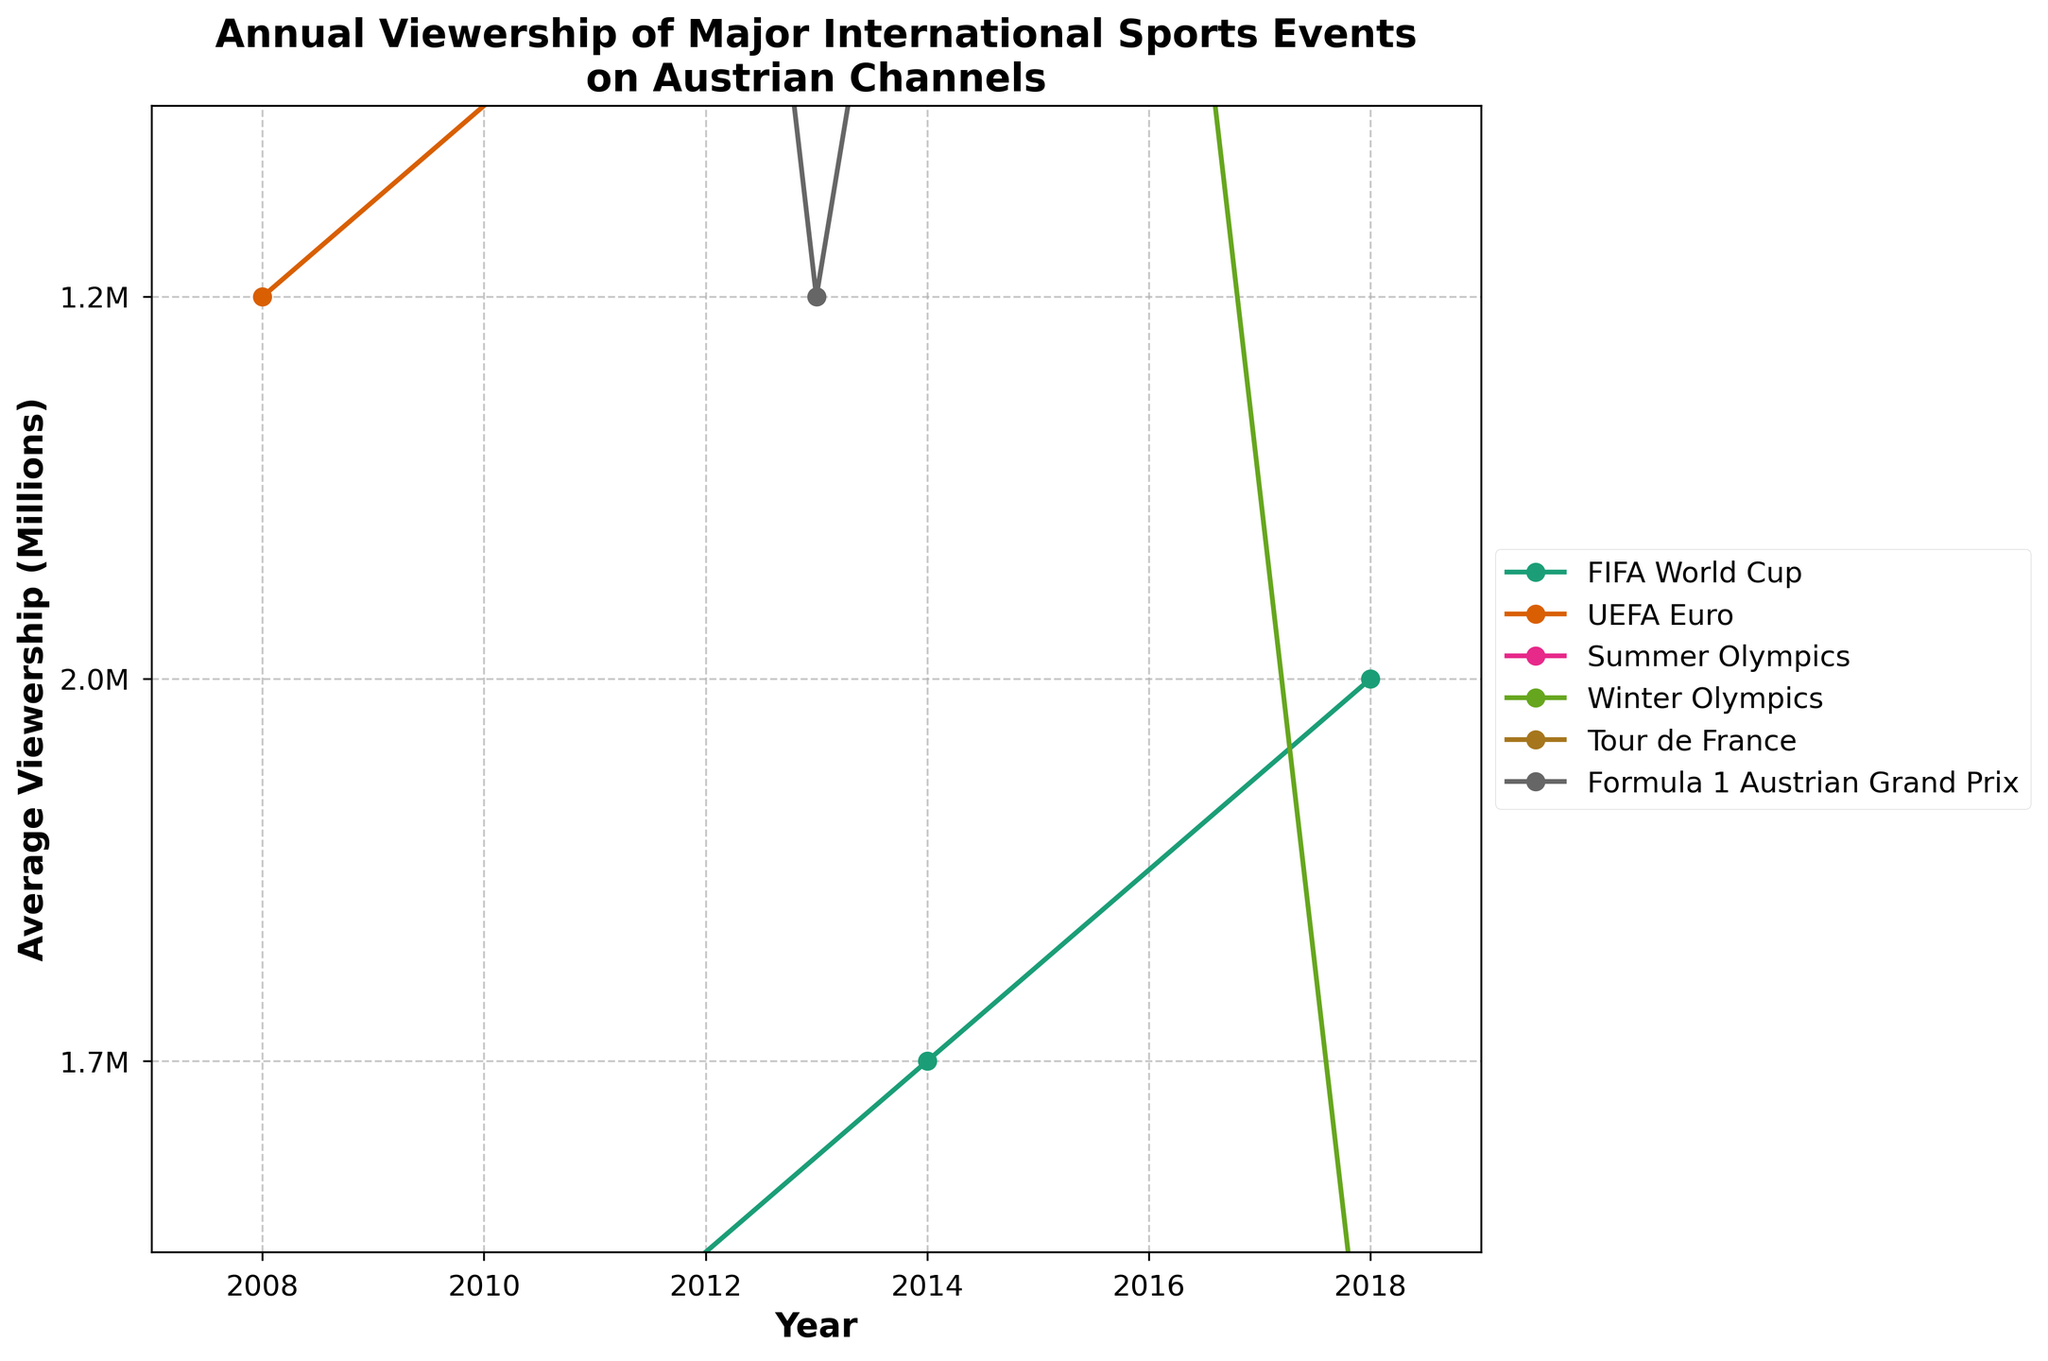What's the title of the plot? The title of the plot is prominently displayed at the top of the figure.
Answer: Annual Viewership of Major International Sports Events on Austrian Channels What is the range of average viewership shown on the y-axis? By examining the y-axis, one can see the minimum and maximum values illustrated.
Answer: 0.5 to 3.5 million Which event had the highest average viewership in any year, and what was the viewership? Identify the highest point across all lines and read the corresponding y-value and event.
Answer: Summer Olympics 2016, 2.9 million How did the viewership of the UEFA Euro change from 2012 to 2016? Trace the line representing UEFA Euro from 2012 to 2016 and observe the change in y-values.
Answer: Increased from 1.4 million to 1.8 million In which year did the Winter Olympics surpass 1.0 million viewers? Locate the Winter Olympics line and find the first year where the y-value exceeds 1.0 million.
Answer: 2010 What is the average viewership of the FIFA World Cup over the displayed years? Calculate the mean of the average viewership values for the FIFA World Cup years provided.
Answer: (1.5 + 1.7 + 2.0) / 3 = 1.73 million Compare the viewership of the Summer Olympics and Winter Olympics in 2010. Which was higher, and by how much? Compare the y-values for both events in 2010 and subtract the Winter Olympics viewership from the Summer Olympics viewership.
Answer: Summer Olympics, 1.4 million more Which event showed no increase in viewership over the displayed years? Identify the event where the plotted line remains consistent or shows no upward trend in y-values.
Answer: None, all events showed an increase How does the viewership trend of Tour de France compare to the Formula 1 Austrian Grand Prix from 2008 to 2016? Compare the slopes of the lines representing both events over the specified years.
Answer: Both showed an increasing trend, but Formula 1 had a greater increase What is the overall trend in viewership for all sports events from 2008 to 2018? Observe the general direction of all the lines from start to end years to determine the trend.
Answer: Increasing 